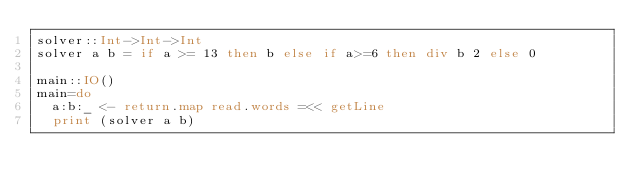<code> <loc_0><loc_0><loc_500><loc_500><_Haskell_>solver::Int->Int->Int
solver a b = if a >= 13 then b else if a>=6 then div b 2 else 0

main::IO()
main=do
  a:b:_ <- return.map read.words =<< getLine
  print (solver a b)
  
</code> 